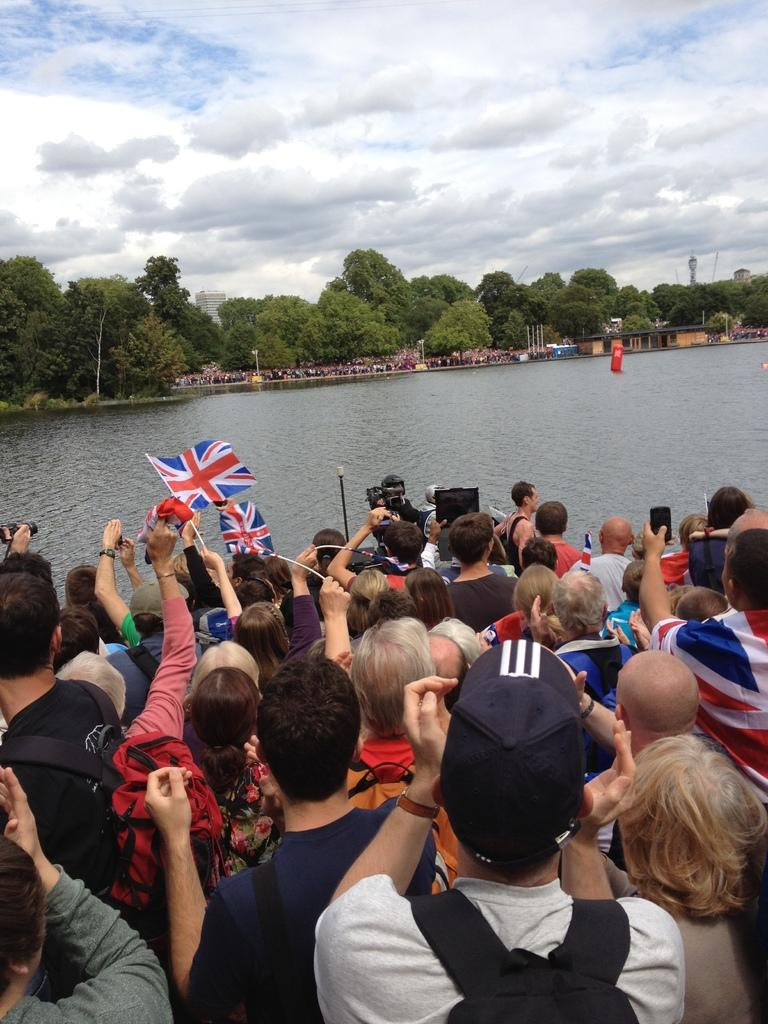How many people are in the image? There is a group of people in the image, but the exact number cannot be determined from the provided facts. What are some people doing in the image? Some people are holding flags in the image. What can be seen in the background of the image? Water, trees, clouds, and a building are visible in the background of the image. Where are the toys stored in the image? There are no toys present in the image. What type of cellar can be seen in the image? There is no cellar present in the image. 